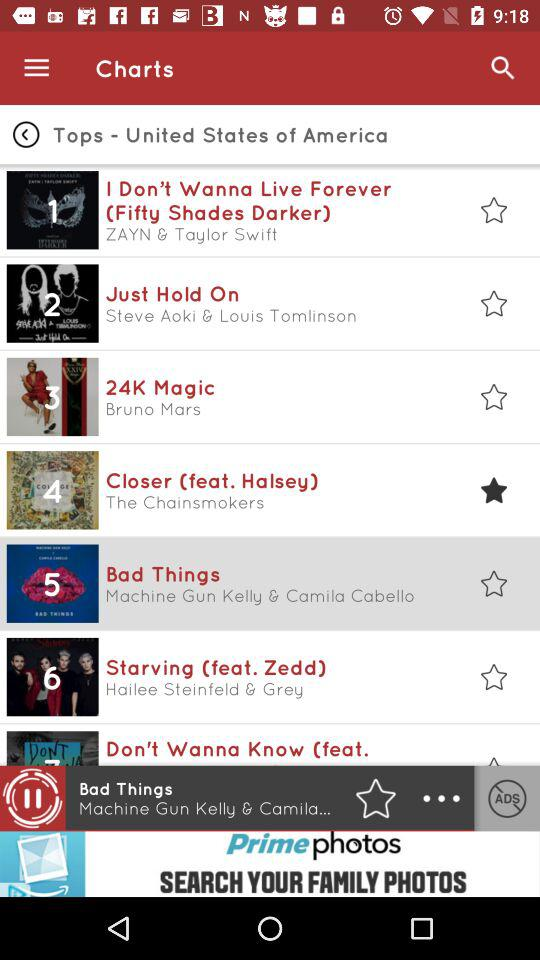Which song is selected as the favorite? The song is "Closer (feat. Halsey)". 